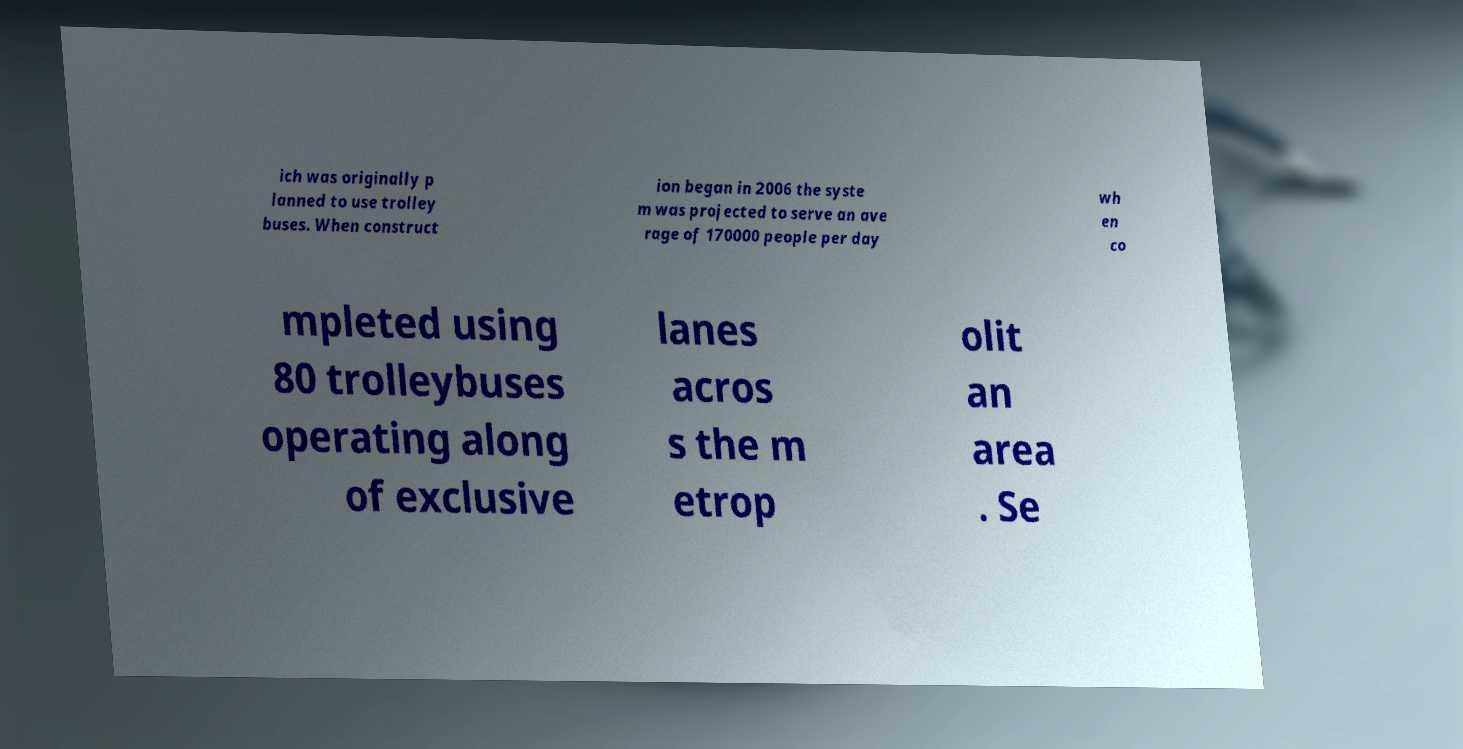Please identify and transcribe the text found in this image. ich was originally p lanned to use trolley buses. When construct ion began in 2006 the syste m was projected to serve an ave rage of 170000 people per day wh en co mpleted using 80 trolleybuses operating along of exclusive lanes acros s the m etrop olit an area . Se 